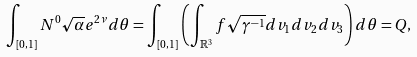Convert formula to latex. <formula><loc_0><loc_0><loc_500><loc_500>\int _ { [ 0 , 1 ] } N ^ { 0 } \sqrt { \alpha } e ^ { 2 \nu } d \theta = \int _ { [ 0 , 1 ] } \left ( \int _ { \mathbb { R } ^ { 3 } } f \sqrt { \gamma ^ { - 1 } } d v _ { 1 } d v _ { 2 } d v _ { 3 } \right ) d \theta = Q ,</formula> 